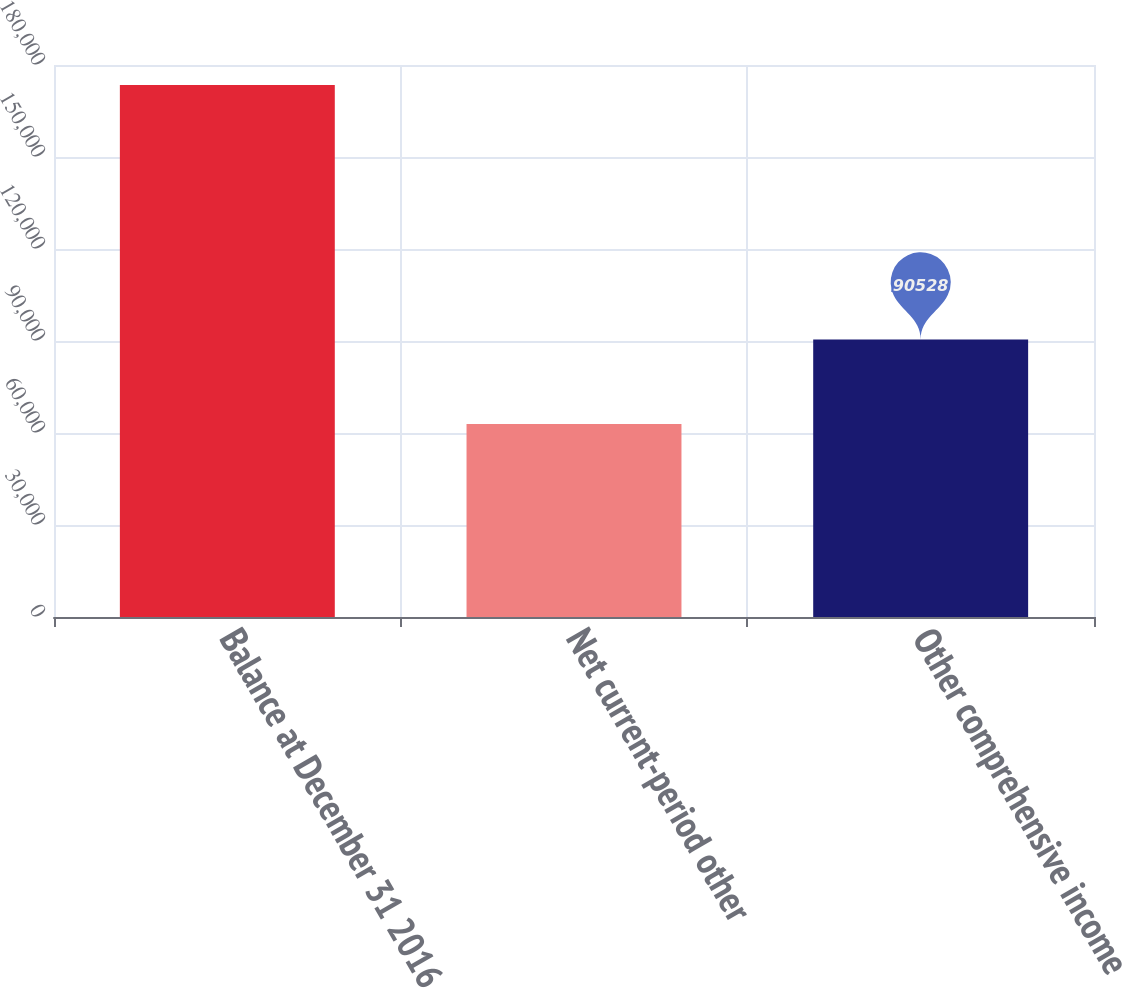<chart> <loc_0><loc_0><loc_500><loc_500><bar_chart><fcel>Balance at December 31 2016<fcel>Net current-period other<fcel>Other comprehensive income<nl><fcel>173496<fcel>62915<fcel>90528<nl></chart> 